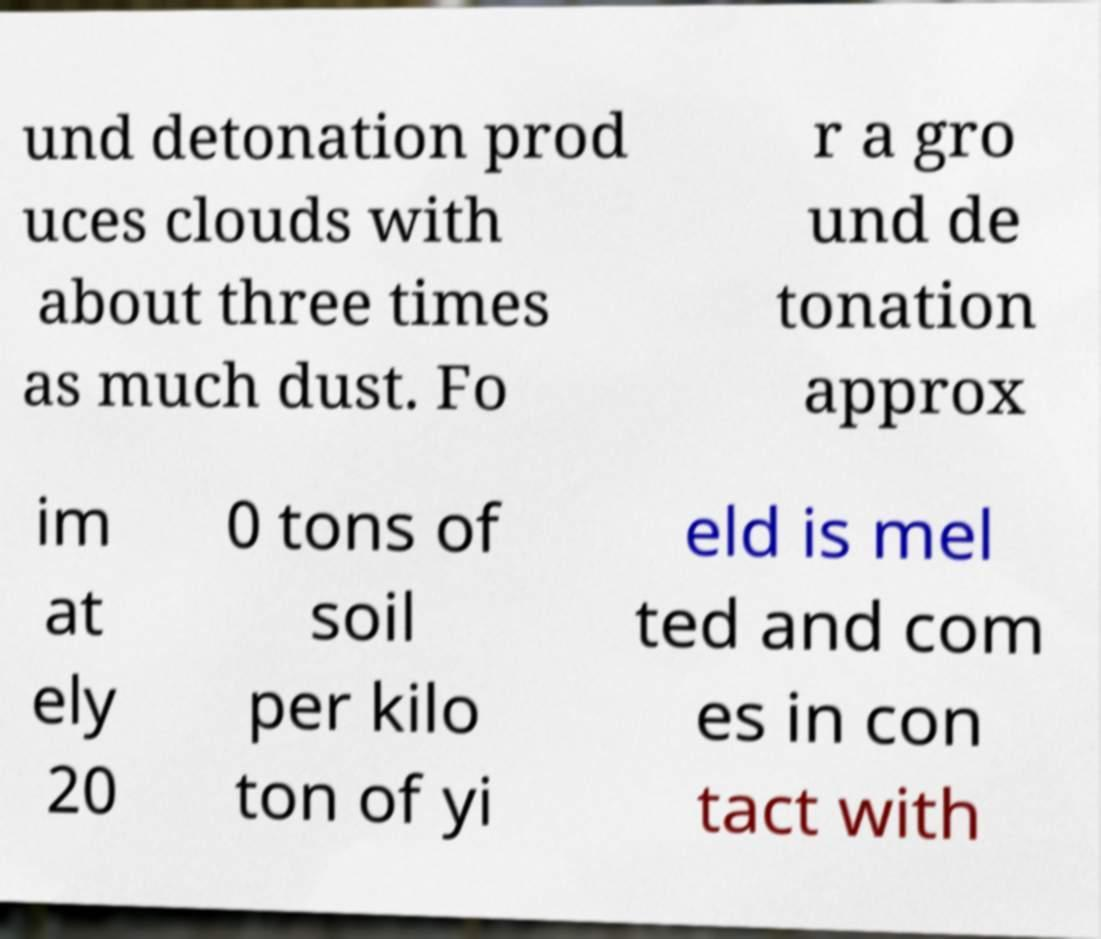Please identify and transcribe the text found in this image. und detonation prod uces clouds with about three times as much dust. Fo r a gro und de tonation approx im at ely 20 0 tons of soil per kilo ton of yi eld is mel ted and com es in con tact with 